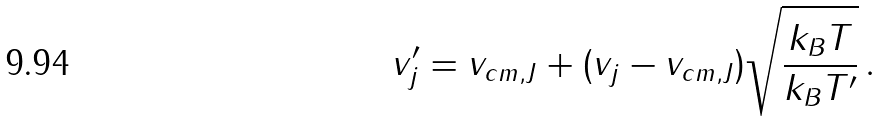Convert formula to latex. <formula><loc_0><loc_0><loc_500><loc_500>v ^ { \prime } _ { j } = v _ { c m , J } + ( v _ { j } - v _ { c m , J } ) \sqrt { \frac { k _ { B } T } { k _ { B } T ^ { \prime } } } \, .</formula> 